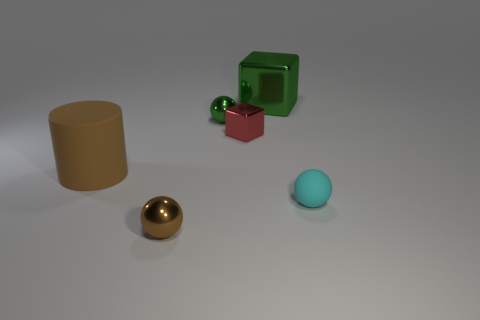Add 2 tiny cyan matte cylinders. How many objects exist? 8 Subtract all blocks. How many objects are left? 4 Subtract 0 yellow balls. How many objects are left? 6 Subtract all big yellow matte spheres. Subtract all small brown things. How many objects are left? 5 Add 4 matte cylinders. How many matte cylinders are left? 5 Add 6 large green things. How many large green things exist? 7 